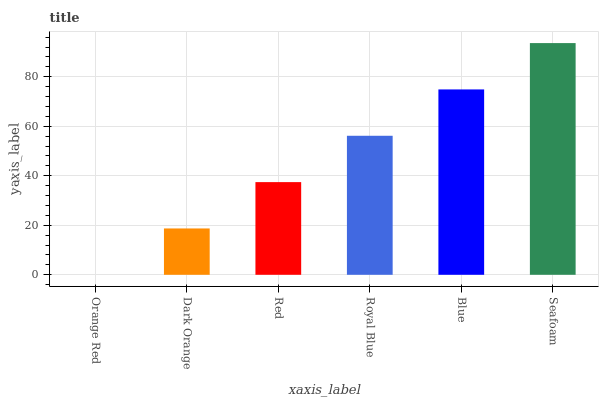Is Orange Red the minimum?
Answer yes or no. Yes. Is Seafoam the maximum?
Answer yes or no. Yes. Is Dark Orange the minimum?
Answer yes or no. No. Is Dark Orange the maximum?
Answer yes or no. No. Is Dark Orange greater than Orange Red?
Answer yes or no. Yes. Is Orange Red less than Dark Orange?
Answer yes or no. Yes. Is Orange Red greater than Dark Orange?
Answer yes or no. No. Is Dark Orange less than Orange Red?
Answer yes or no. No. Is Royal Blue the high median?
Answer yes or no. Yes. Is Red the low median?
Answer yes or no. Yes. Is Blue the high median?
Answer yes or no. No. Is Orange Red the low median?
Answer yes or no. No. 